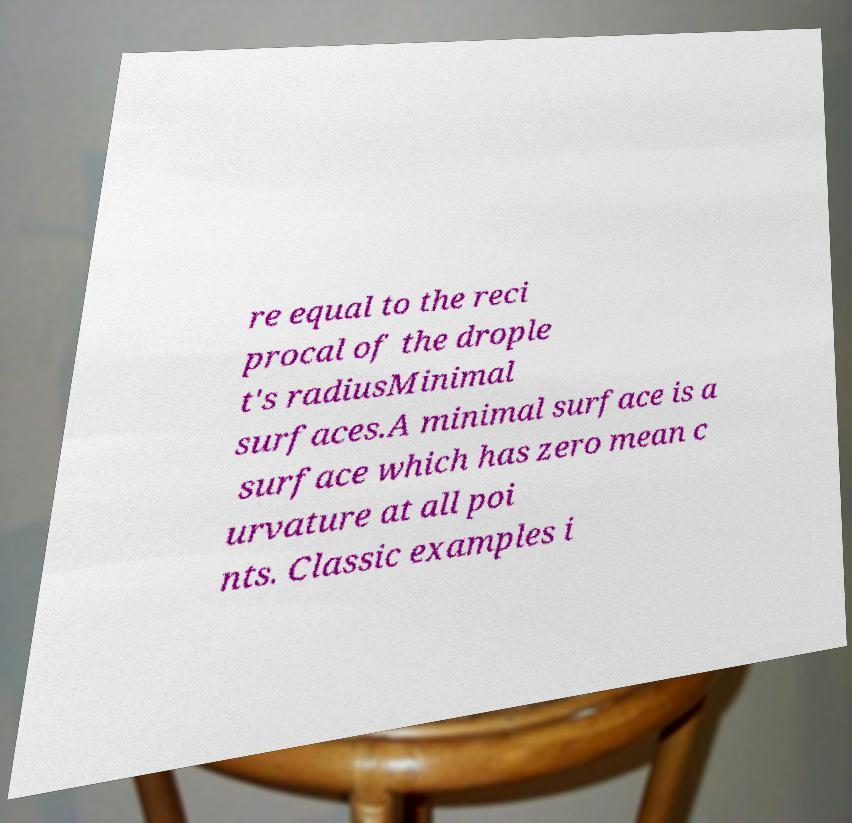Please read and relay the text visible in this image. What does it say? re equal to the reci procal of the drople t's radiusMinimal surfaces.A minimal surface is a surface which has zero mean c urvature at all poi nts. Classic examples i 